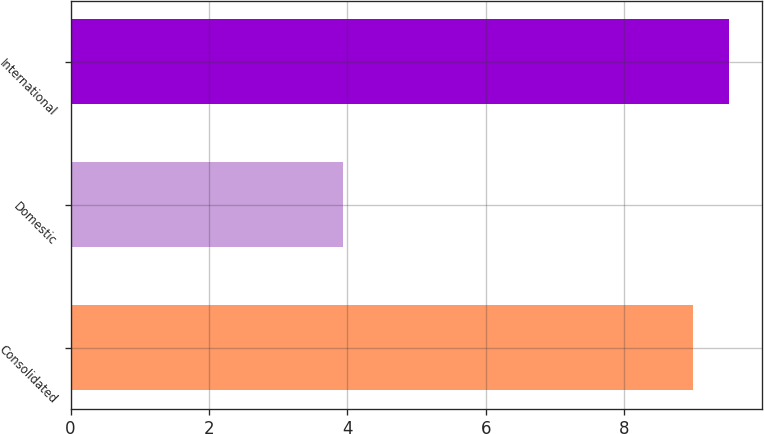Convert chart. <chart><loc_0><loc_0><loc_500><loc_500><bar_chart><fcel>Consolidated<fcel>Domestic<fcel>International<nl><fcel>9<fcel>3.94<fcel>9.51<nl></chart> 